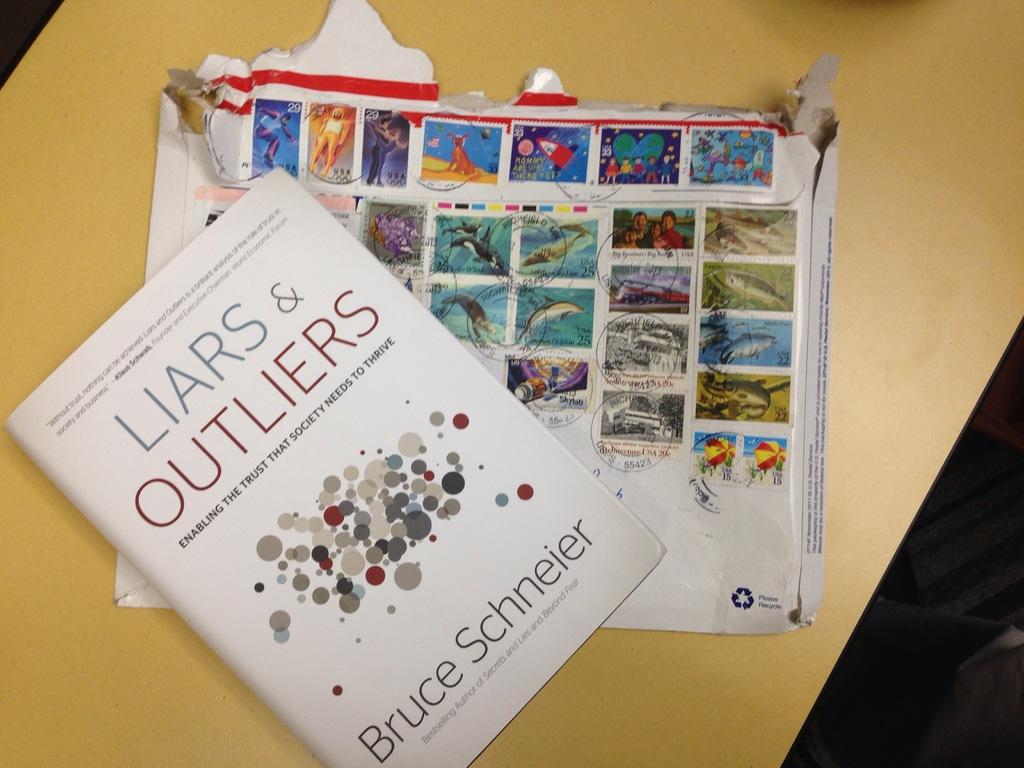Who is the author of liars and outliers?
Your answer should be very brief. Bruce schneier. How many red dots are on the front page?
Provide a succinct answer. Answering does not require reading text in the image. 